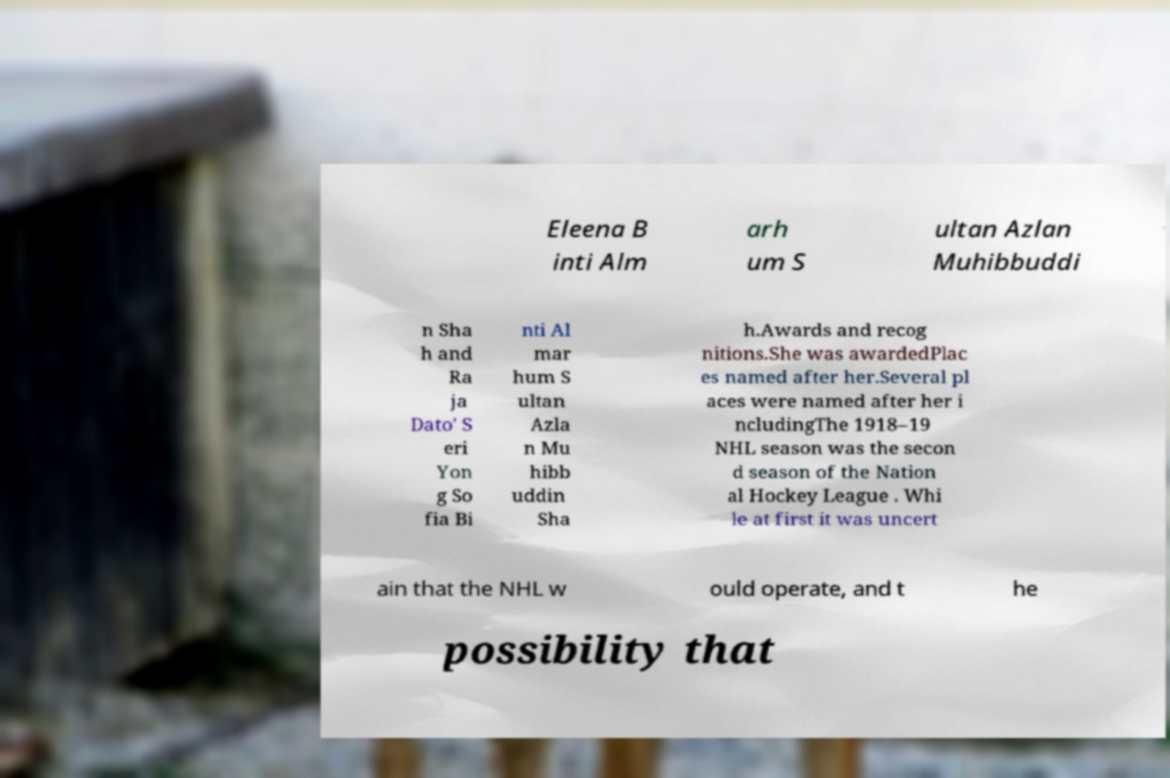Could you assist in decoding the text presented in this image and type it out clearly? Eleena B inti Alm arh um S ultan Azlan Muhibbuddi n Sha h and Ra ja Dato' S eri Yon g So fia Bi nti Al mar hum S ultan Azla n Mu hibb uddin Sha h.Awards and recog nitions.She was awardedPlac es named after her.Several pl aces were named after her i ncludingThe 1918–19 NHL season was the secon d season of the Nation al Hockey League . Whi le at first it was uncert ain that the NHL w ould operate, and t he possibility that 